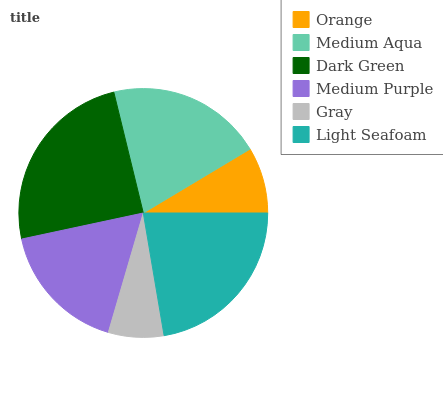Is Gray the minimum?
Answer yes or no. Yes. Is Dark Green the maximum?
Answer yes or no. Yes. Is Medium Aqua the minimum?
Answer yes or no. No. Is Medium Aqua the maximum?
Answer yes or no. No. Is Medium Aqua greater than Orange?
Answer yes or no. Yes. Is Orange less than Medium Aqua?
Answer yes or no. Yes. Is Orange greater than Medium Aqua?
Answer yes or no. No. Is Medium Aqua less than Orange?
Answer yes or no. No. Is Medium Aqua the high median?
Answer yes or no. Yes. Is Medium Purple the low median?
Answer yes or no. Yes. Is Medium Purple the high median?
Answer yes or no. No. Is Dark Green the low median?
Answer yes or no. No. 